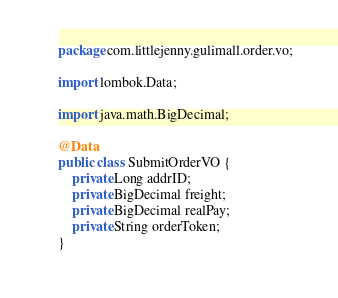Convert code to text. <code><loc_0><loc_0><loc_500><loc_500><_Java_>package com.littlejenny.gulimall.order.vo;

import lombok.Data;

import java.math.BigDecimal;

@Data
public class SubmitOrderVO {
    private Long addrID;
    private BigDecimal freight;
    private BigDecimal realPay;
    private String orderToken;
}
</code> 